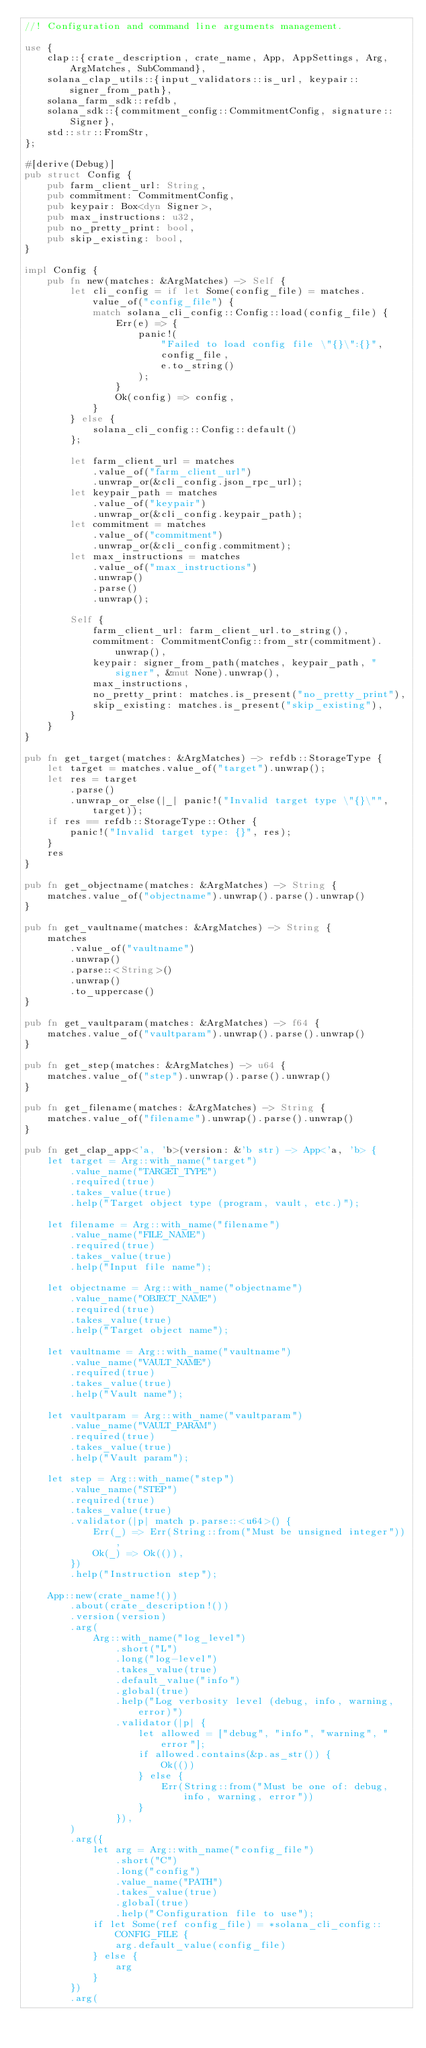<code> <loc_0><loc_0><loc_500><loc_500><_Rust_>//! Configuration and command line arguments management.

use {
    clap::{crate_description, crate_name, App, AppSettings, Arg, ArgMatches, SubCommand},
    solana_clap_utils::{input_validators::is_url, keypair::signer_from_path},
    solana_farm_sdk::refdb,
    solana_sdk::{commitment_config::CommitmentConfig, signature::Signer},
    std::str::FromStr,
};

#[derive(Debug)]
pub struct Config {
    pub farm_client_url: String,
    pub commitment: CommitmentConfig,
    pub keypair: Box<dyn Signer>,
    pub max_instructions: u32,
    pub no_pretty_print: bool,
    pub skip_existing: bool,
}

impl Config {
    pub fn new(matches: &ArgMatches) -> Self {
        let cli_config = if let Some(config_file) = matches.value_of("config_file") {
            match solana_cli_config::Config::load(config_file) {
                Err(e) => {
                    panic!(
                        "Failed to load config file \"{}\":{}",
                        config_file,
                        e.to_string()
                    );
                }
                Ok(config) => config,
            }
        } else {
            solana_cli_config::Config::default()
        };

        let farm_client_url = matches
            .value_of("farm_client_url")
            .unwrap_or(&cli_config.json_rpc_url);
        let keypair_path = matches
            .value_of("keypair")
            .unwrap_or(&cli_config.keypair_path);
        let commitment = matches
            .value_of("commitment")
            .unwrap_or(&cli_config.commitment);
        let max_instructions = matches
            .value_of("max_instructions")
            .unwrap()
            .parse()
            .unwrap();

        Self {
            farm_client_url: farm_client_url.to_string(),
            commitment: CommitmentConfig::from_str(commitment).unwrap(),
            keypair: signer_from_path(matches, keypair_path, "signer", &mut None).unwrap(),
            max_instructions,
            no_pretty_print: matches.is_present("no_pretty_print"),
            skip_existing: matches.is_present("skip_existing"),
        }
    }
}

pub fn get_target(matches: &ArgMatches) -> refdb::StorageType {
    let target = matches.value_of("target").unwrap();
    let res = target
        .parse()
        .unwrap_or_else(|_| panic!("Invalid target type \"{}\"", target));
    if res == refdb::StorageType::Other {
        panic!("Invalid target type: {}", res);
    }
    res
}

pub fn get_objectname(matches: &ArgMatches) -> String {
    matches.value_of("objectname").unwrap().parse().unwrap()
}

pub fn get_vaultname(matches: &ArgMatches) -> String {
    matches
        .value_of("vaultname")
        .unwrap()
        .parse::<String>()
        .unwrap()
        .to_uppercase()
}

pub fn get_vaultparam(matches: &ArgMatches) -> f64 {
    matches.value_of("vaultparam").unwrap().parse().unwrap()
}

pub fn get_step(matches: &ArgMatches) -> u64 {
    matches.value_of("step").unwrap().parse().unwrap()
}

pub fn get_filename(matches: &ArgMatches) -> String {
    matches.value_of("filename").unwrap().parse().unwrap()
}

pub fn get_clap_app<'a, 'b>(version: &'b str) -> App<'a, 'b> {
    let target = Arg::with_name("target")
        .value_name("TARGET_TYPE")
        .required(true)
        .takes_value(true)
        .help("Target object type (program, vault, etc.)");

    let filename = Arg::with_name("filename")
        .value_name("FILE_NAME")
        .required(true)
        .takes_value(true)
        .help("Input file name");

    let objectname = Arg::with_name("objectname")
        .value_name("OBJECT_NAME")
        .required(true)
        .takes_value(true)
        .help("Target object name");

    let vaultname = Arg::with_name("vaultname")
        .value_name("VAULT_NAME")
        .required(true)
        .takes_value(true)
        .help("Vault name");

    let vaultparam = Arg::with_name("vaultparam")
        .value_name("VAULT_PARAM")
        .required(true)
        .takes_value(true)
        .help("Vault param");

    let step = Arg::with_name("step")
        .value_name("STEP")
        .required(true)
        .takes_value(true)
        .validator(|p| match p.parse::<u64>() {
            Err(_) => Err(String::from("Must be unsigned integer")),
            Ok(_) => Ok(()),
        })
        .help("Instruction step");

    App::new(crate_name!())
        .about(crate_description!())
        .version(version)
        .arg(
            Arg::with_name("log_level")
                .short("L")
                .long("log-level")
                .takes_value(true)
                .default_value("info")
                .global(true)
                .help("Log verbosity level (debug, info, warning, error)")
                .validator(|p| {
                    let allowed = ["debug", "info", "warning", "error"];
                    if allowed.contains(&p.as_str()) {
                        Ok(())
                    } else {
                        Err(String::from("Must be one of: debug, info, warning, error"))
                    }
                }),
        )
        .arg({
            let arg = Arg::with_name("config_file")
                .short("C")
                .long("config")
                .value_name("PATH")
                .takes_value(true)
                .global(true)
                .help("Configuration file to use");
            if let Some(ref config_file) = *solana_cli_config::CONFIG_FILE {
                arg.default_value(config_file)
            } else {
                arg
            }
        })
        .arg(</code> 